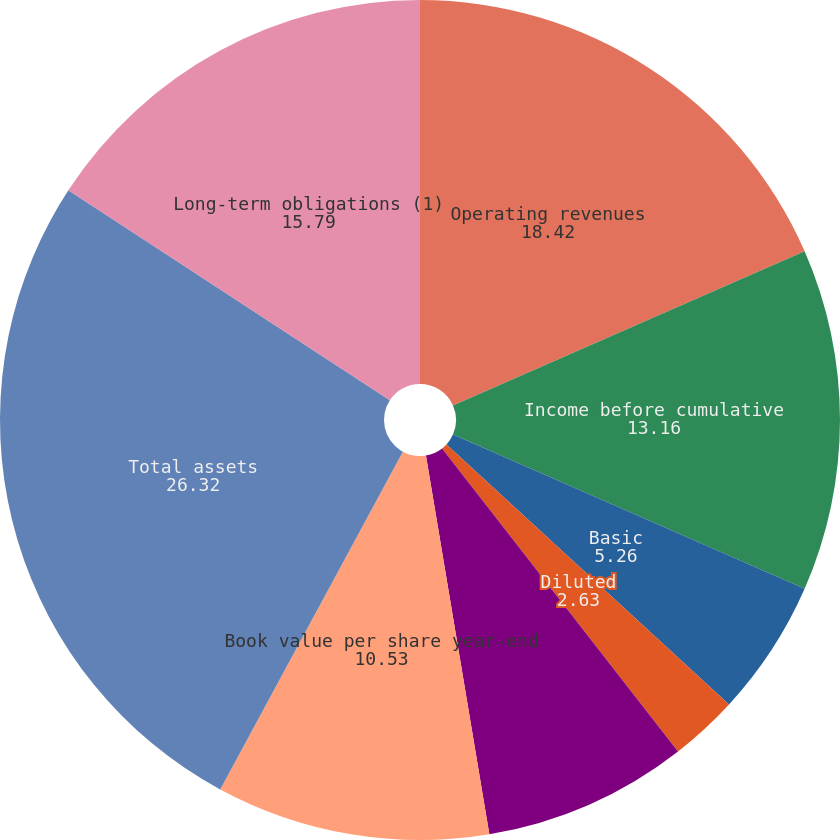<chart> <loc_0><loc_0><loc_500><loc_500><pie_chart><fcel>Operating revenues<fcel>Income before cumulative<fcel>Basic<fcel>Diluted<fcel>Dividends declared per share<fcel>Return on common equity<fcel>Book value per share year-end<fcel>Total assets<fcel>Long-term obligations (1)<nl><fcel>18.42%<fcel>13.16%<fcel>5.26%<fcel>2.63%<fcel>0.0%<fcel>7.89%<fcel>10.53%<fcel>26.32%<fcel>15.79%<nl></chart> 